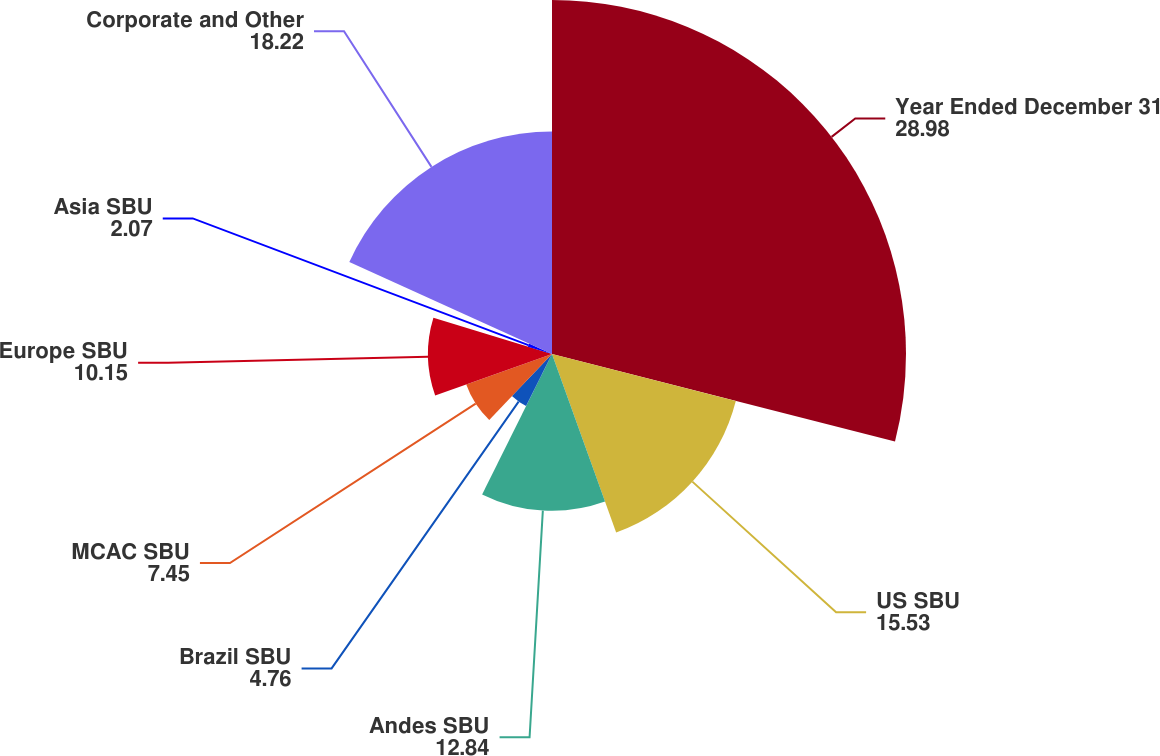Convert chart to OTSL. <chart><loc_0><loc_0><loc_500><loc_500><pie_chart><fcel>Year Ended December 31<fcel>US SBU<fcel>Andes SBU<fcel>Brazil SBU<fcel>MCAC SBU<fcel>Europe SBU<fcel>Asia SBU<fcel>Corporate and Other<nl><fcel>28.98%<fcel>15.53%<fcel>12.84%<fcel>4.76%<fcel>7.45%<fcel>10.15%<fcel>2.07%<fcel>18.22%<nl></chart> 